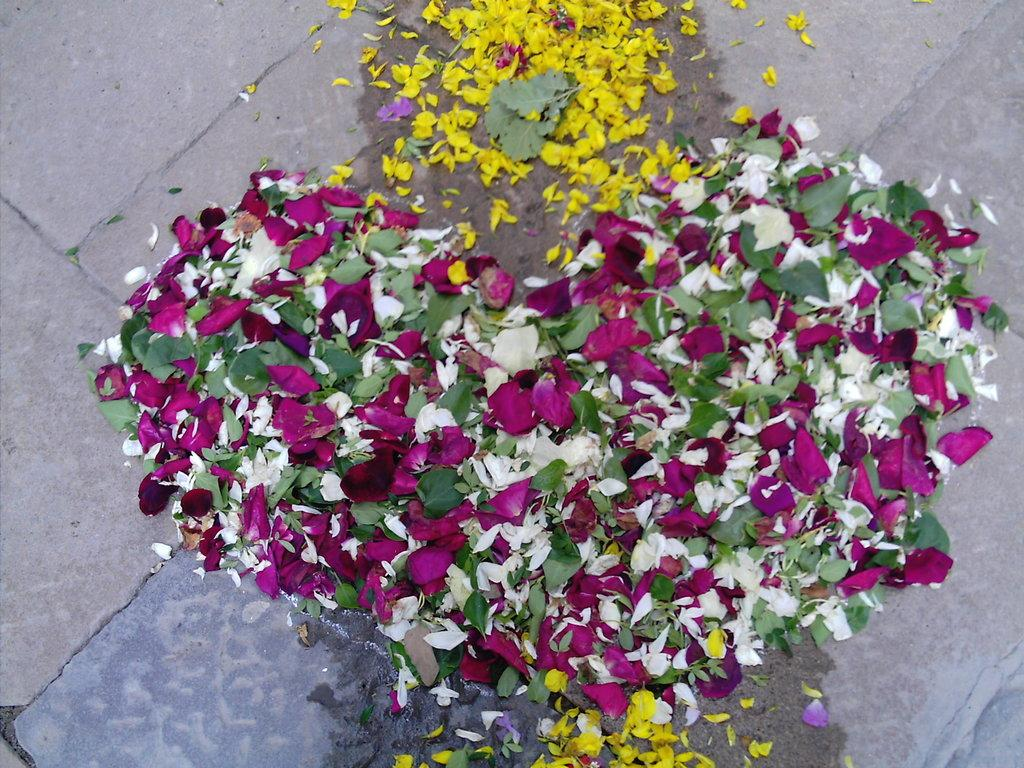What is on the floor in the image? There are flower petals on the floor in the image. What colors can be seen among the flower petals? The petals are in pink, green, yellow, and white colors. What type of authority figure can be seen in the image? There is no authority figure present in the image; it only features flower petals on the floor. 